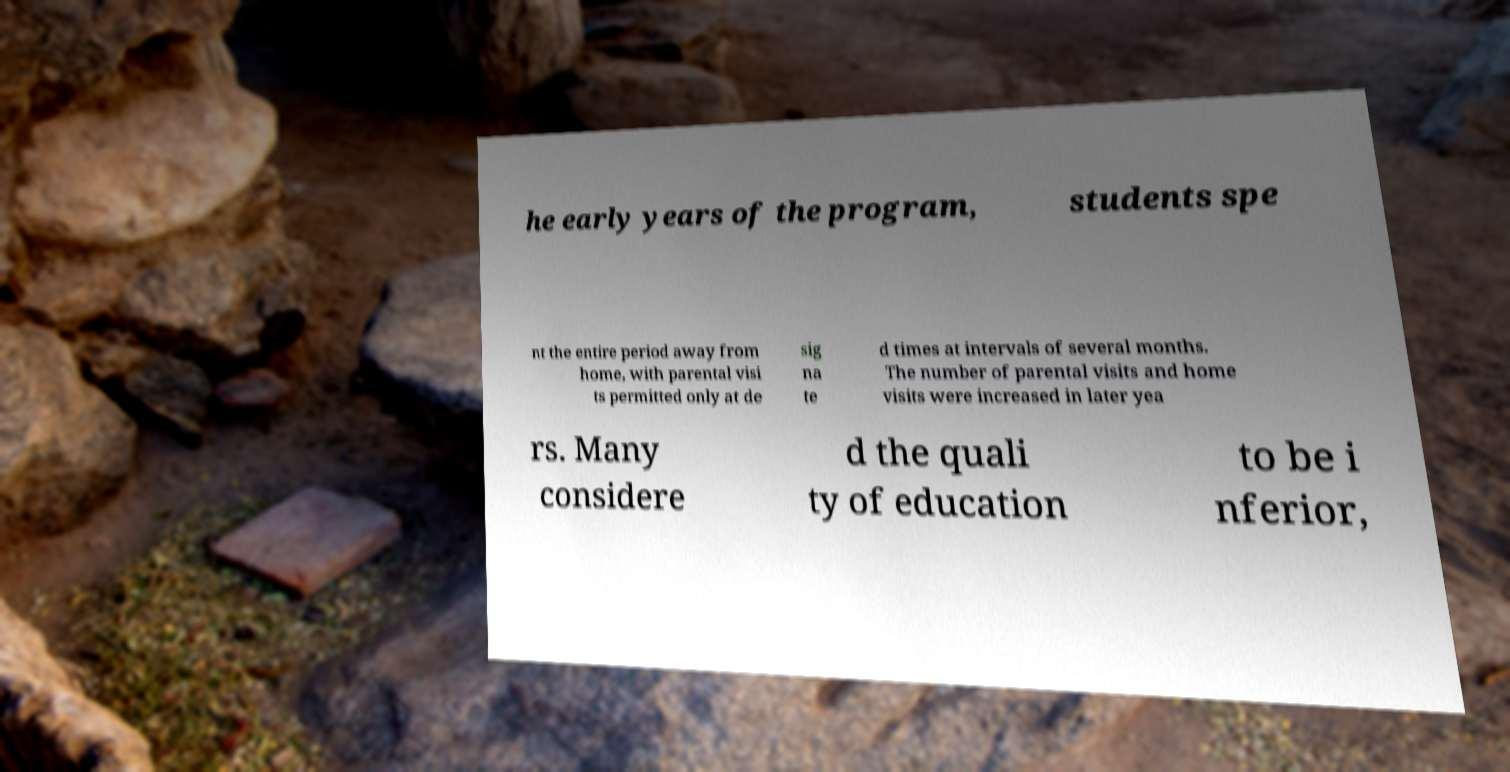What messages or text are displayed in this image? I need them in a readable, typed format. he early years of the program, students spe nt the entire period away from home, with parental visi ts permitted only at de sig na te d times at intervals of several months. The number of parental visits and home visits were increased in later yea rs. Many considere d the quali ty of education to be i nferior, 